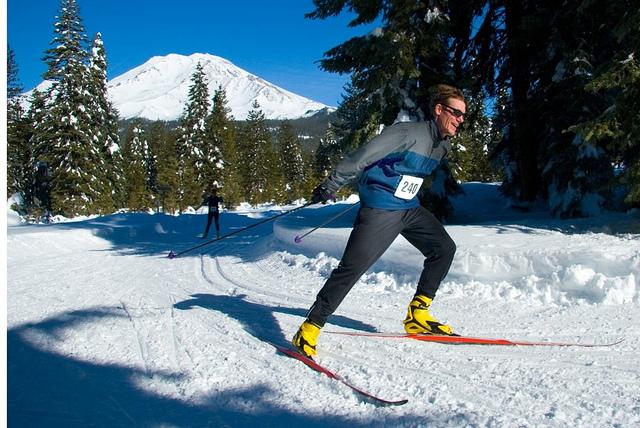What number is this skier?
Concise answer only. 240. What color pants is this person wearing?
Concise answer only. Black. How many skiers are on the descent?
Quick response, please. 2. What's the purpose of the man's yellow shoes?
Concise answer only. Skiing. 